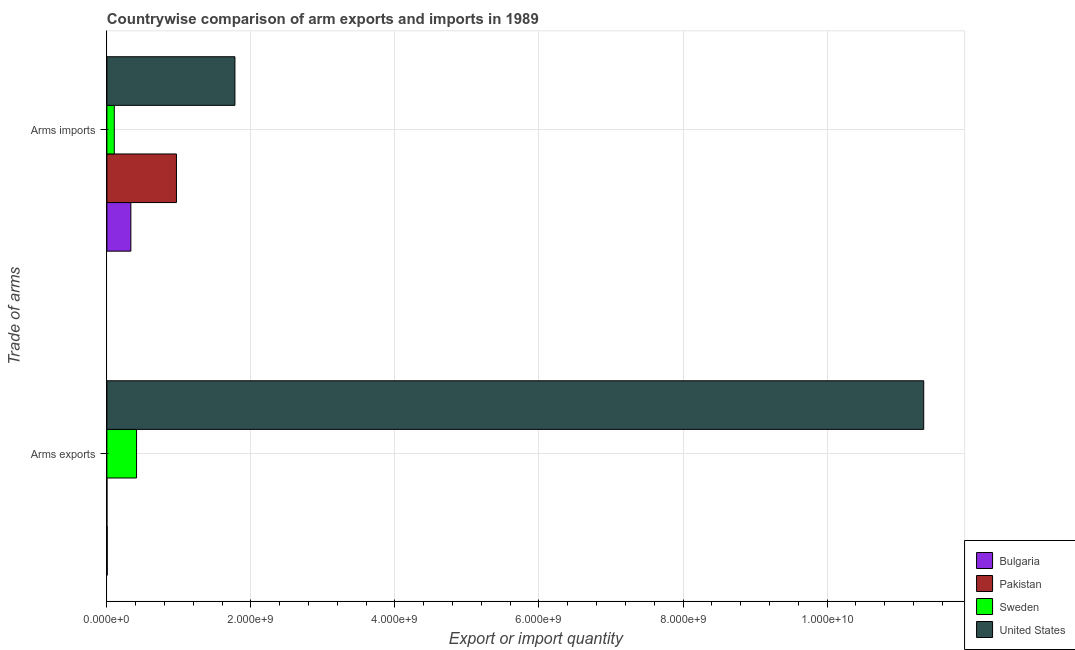How many groups of bars are there?
Make the answer very short. 2. How many bars are there on the 2nd tick from the top?
Provide a short and direct response. 4. What is the label of the 2nd group of bars from the top?
Your answer should be very brief. Arms exports. What is the arms exports in Sweden?
Keep it short and to the point. 4.12e+08. Across all countries, what is the maximum arms exports?
Your answer should be compact. 1.13e+1. Across all countries, what is the minimum arms exports?
Your answer should be very brief. 1.00e+06. What is the total arms exports in the graph?
Provide a short and direct response. 1.18e+1. What is the difference between the arms imports in United States and that in Sweden?
Offer a very short reply. 1.68e+09. What is the difference between the arms imports in Sweden and the arms exports in United States?
Your answer should be very brief. -1.12e+1. What is the average arms imports per country?
Your answer should be very brief. 7.95e+08. What is the difference between the arms imports and arms exports in United States?
Provide a succinct answer. -9.56e+09. What is the ratio of the arms imports in United States to that in Pakistan?
Make the answer very short. 1.84. Are all the bars in the graph horizontal?
Offer a very short reply. Yes. How many countries are there in the graph?
Your response must be concise. 4. Are the values on the major ticks of X-axis written in scientific E-notation?
Provide a short and direct response. Yes. What is the title of the graph?
Ensure brevity in your answer.  Countrywise comparison of arm exports and imports in 1989. Does "Finland" appear as one of the legend labels in the graph?
Offer a very short reply. No. What is the label or title of the X-axis?
Your answer should be very brief. Export or import quantity. What is the label or title of the Y-axis?
Offer a very short reply. Trade of arms. What is the Export or import quantity of Sweden in Arms exports?
Your answer should be compact. 4.12e+08. What is the Export or import quantity in United States in Arms exports?
Your response must be concise. 1.13e+1. What is the Export or import quantity of Bulgaria in Arms imports?
Your answer should be very brief. 3.33e+08. What is the Export or import quantity of Pakistan in Arms imports?
Make the answer very short. 9.66e+08. What is the Export or import quantity of Sweden in Arms imports?
Provide a succinct answer. 1.03e+08. What is the Export or import quantity of United States in Arms imports?
Your answer should be very brief. 1.78e+09. Across all Trade of arms, what is the maximum Export or import quantity of Bulgaria?
Make the answer very short. 3.33e+08. Across all Trade of arms, what is the maximum Export or import quantity in Pakistan?
Ensure brevity in your answer.  9.66e+08. Across all Trade of arms, what is the maximum Export or import quantity in Sweden?
Offer a very short reply. 4.12e+08. Across all Trade of arms, what is the maximum Export or import quantity of United States?
Provide a short and direct response. 1.13e+1. Across all Trade of arms, what is the minimum Export or import quantity of Bulgaria?
Your answer should be compact. 5.00e+06. Across all Trade of arms, what is the minimum Export or import quantity in Sweden?
Give a very brief answer. 1.03e+08. Across all Trade of arms, what is the minimum Export or import quantity in United States?
Offer a terse response. 1.78e+09. What is the total Export or import quantity of Bulgaria in the graph?
Provide a short and direct response. 3.38e+08. What is the total Export or import quantity of Pakistan in the graph?
Provide a succinct answer. 9.67e+08. What is the total Export or import quantity in Sweden in the graph?
Ensure brevity in your answer.  5.15e+08. What is the total Export or import quantity in United States in the graph?
Provide a succinct answer. 1.31e+1. What is the difference between the Export or import quantity in Bulgaria in Arms exports and that in Arms imports?
Offer a terse response. -3.28e+08. What is the difference between the Export or import quantity in Pakistan in Arms exports and that in Arms imports?
Give a very brief answer. -9.65e+08. What is the difference between the Export or import quantity of Sweden in Arms exports and that in Arms imports?
Your response must be concise. 3.09e+08. What is the difference between the Export or import quantity in United States in Arms exports and that in Arms imports?
Ensure brevity in your answer.  9.56e+09. What is the difference between the Export or import quantity in Bulgaria in Arms exports and the Export or import quantity in Pakistan in Arms imports?
Offer a very short reply. -9.61e+08. What is the difference between the Export or import quantity in Bulgaria in Arms exports and the Export or import quantity in Sweden in Arms imports?
Offer a very short reply. -9.80e+07. What is the difference between the Export or import quantity in Bulgaria in Arms exports and the Export or import quantity in United States in Arms imports?
Give a very brief answer. -1.77e+09. What is the difference between the Export or import quantity of Pakistan in Arms exports and the Export or import quantity of Sweden in Arms imports?
Provide a short and direct response. -1.02e+08. What is the difference between the Export or import quantity in Pakistan in Arms exports and the Export or import quantity in United States in Arms imports?
Your response must be concise. -1.78e+09. What is the difference between the Export or import quantity in Sweden in Arms exports and the Export or import quantity in United States in Arms imports?
Provide a short and direct response. -1.37e+09. What is the average Export or import quantity of Bulgaria per Trade of arms?
Your response must be concise. 1.69e+08. What is the average Export or import quantity in Pakistan per Trade of arms?
Make the answer very short. 4.84e+08. What is the average Export or import quantity in Sweden per Trade of arms?
Keep it short and to the point. 2.58e+08. What is the average Export or import quantity in United States per Trade of arms?
Offer a very short reply. 6.56e+09. What is the difference between the Export or import quantity in Bulgaria and Export or import quantity in Sweden in Arms exports?
Provide a short and direct response. -4.07e+08. What is the difference between the Export or import quantity of Bulgaria and Export or import quantity of United States in Arms exports?
Provide a short and direct response. -1.13e+1. What is the difference between the Export or import quantity of Pakistan and Export or import quantity of Sweden in Arms exports?
Provide a short and direct response. -4.11e+08. What is the difference between the Export or import quantity of Pakistan and Export or import quantity of United States in Arms exports?
Ensure brevity in your answer.  -1.13e+1. What is the difference between the Export or import quantity of Sweden and Export or import quantity of United States in Arms exports?
Provide a succinct answer. -1.09e+1. What is the difference between the Export or import quantity in Bulgaria and Export or import quantity in Pakistan in Arms imports?
Offer a very short reply. -6.33e+08. What is the difference between the Export or import quantity of Bulgaria and Export or import quantity of Sweden in Arms imports?
Your answer should be very brief. 2.30e+08. What is the difference between the Export or import quantity in Bulgaria and Export or import quantity in United States in Arms imports?
Offer a very short reply. -1.44e+09. What is the difference between the Export or import quantity in Pakistan and Export or import quantity in Sweden in Arms imports?
Provide a short and direct response. 8.63e+08. What is the difference between the Export or import quantity in Pakistan and Export or import quantity in United States in Arms imports?
Provide a succinct answer. -8.12e+08. What is the difference between the Export or import quantity in Sweden and Export or import quantity in United States in Arms imports?
Ensure brevity in your answer.  -1.68e+09. What is the ratio of the Export or import quantity in Bulgaria in Arms exports to that in Arms imports?
Keep it short and to the point. 0.01. What is the ratio of the Export or import quantity in Sweden in Arms exports to that in Arms imports?
Your answer should be very brief. 4. What is the ratio of the Export or import quantity of United States in Arms exports to that in Arms imports?
Your answer should be very brief. 6.38. What is the difference between the highest and the second highest Export or import quantity of Bulgaria?
Provide a succinct answer. 3.28e+08. What is the difference between the highest and the second highest Export or import quantity of Pakistan?
Keep it short and to the point. 9.65e+08. What is the difference between the highest and the second highest Export or import quantity in Sweden?
Offer a terse response. 3.09e+08. What is the difference between the highest and the second highest Export or import quantity of United States?
Give a very brief answer. 9.56e+09. What is the difference between the highest and the lowest Export or import quantity of Bulgaria?
Make the answer very short. 3.28e+08. What is the difference between the highest and the lowest Export or import quantity of Pakistan?
Provide a short and direct response. 9.65e+08. What is the difference between the highest and the lowest Export or import quantity in Sweden?
Your response must be concise. 3.09e+08. What is the difference between the highest and the lowest Export or import quantity of United States?
Give a very brief answer. 9.56e+09. 